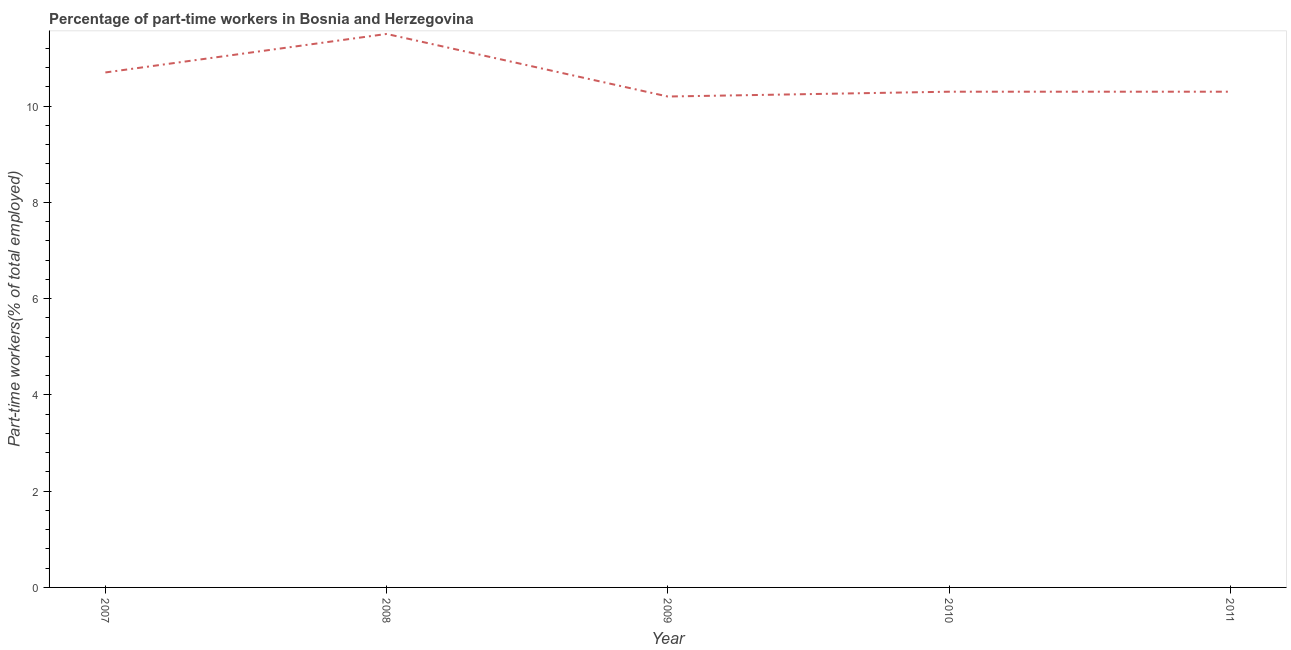What is the percentage of part-time workers in 2010?
Ensure brevity in your answer.  10.3. Across all years, what is the maximum percentage of part-time workers?
Offer a very short reply. 11.5. Across all years, what is the minimum percentage of part-time workers?
Provide a short and direct response. 10.2. In which year was the percentage of part-time workers maximum?
Provide a succinct answer. 2008. In which year was the percentage of part-time workers minimum?
Make the answer very short. 2009. What is the sum of the percentage of part-time workers?
Your answer should be very brief. 53. What is the difference between the percentage of part-time workers in 2008 and 2011?
Your response must be concise. 1.2. What is the average percentage of part-time workers per year?
Offer a very short reply. 10.6. What is the median percentage of part-time workers?
Your answer should be compact. 10.3. Do a majority of the years between 2011 and 2008 (inclusive) have percentage of part-time workers greater than 5.6 %?
Make the answer very short. Yes. What is the ratio of the percentage of part-time workers in 2008 to that in 2010?
Your answer should be compact. 1.12. Is the percentage of part-time workers in 2008 less than that in 2011?
Offer a very short reply. No. Is the difference between the percentage of part-time workers in 2008 and 2011 greater than the difference between any two years?
Offer a terse response. No. What is the difference between the highest and the second highest percentage of part-time workers?
Keep it short and to the point. 0.8. Is the sum of the percentage of part-time workers in 2010 and 2011 greater than the maximum percentage of part-time workers across all years?
Give a very brief answer. Yes. What is the difference between the highest and the lowest percentage of part-time workers?
Ensure brevity in your answer.  1.3. In how many years, is the percentage of part-time workers greater than the average percentage of part-time workers taken over all years?
Your answer should be very brief. 2. Does the percentage of part-time workers monotonically increase over the years?
Offer a very short reply. No. How many lines are there?
Keep it short and to the point. 1. How many years are there in the graph?
Provide a succinct answer. 5. Does the graph contain grids?
Offer a very short reply. No. What is the title of the graph?
Make the answer very short. Percentage of part-time workers in Bosnia and Herzegovina. What is the label or title of the Y-axis?
Offer a very short reply. Part-time workers(% of total employed). What is the Part-time workers(% of total employed) of 2007?
Make the answer very short. 10.7. What is the Part-time workers(% of total employed) in 2009?
Offer a very short reply. 10.2. What is the Part-time workers(% of total employed) of 2010?
Your answer should be very brief. 10.3. What is the Part-time workers(% of total employed) of 2011?
Offer a terse response. 10.3. What is the difference between the Part-time workers(% of total employed) in 2007 and 2010?
Provide a short and direct response. 0.4. What is the difference between the Part-time workers(% of total employed) in 2008 and 2010?
Give a very brief answer. 1.2. What is the difference between the Part-time workers(% of total employed) in 2009 and 2010?
Provide a short and direct response. -0.1. What is the difference between the Part-time workers(% of total employed) in 2010 and 2011?
Keep it short and to the point. 0. What is the ratio of the Part-time workers(% of total employed) in 2007 to that in 2009?
Give a very brief answer. 1.05. What is the ratio of the Part-time workers(% of total employed) in 2007 to that in 2010?
Provide a succinct answer. 1.04. What is the ratio of the Part-time workers(% of total employed) in 2007 to that in 2011?
Offer a very short reply. 1.04. What is the ratio of the Part-time workers(% of total employed) in 2008 to that in 2009?
Offer a very short reply. 1.13. What is the ratio of the Part-time workers(% of total employed) in 2008 to that in 2010?
Provide a short and direct response. 1.12. What is the ratio of the Part-time workers(% of total employed) in 2008 to that in 2011?
Offer a terse response. 1.12. What is the ratio of the Part-time workers(% of total employed) in 2010 to that in 2011?
Offer a terse response. 1. 